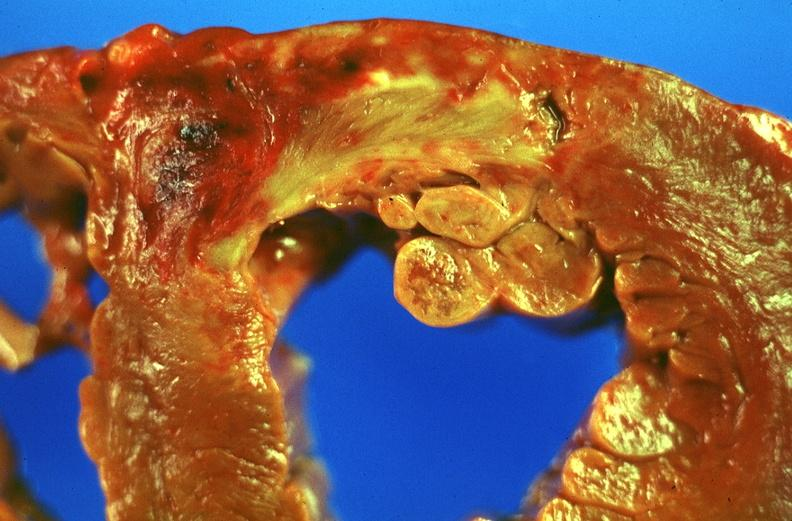what does this image show?
Answer the question using a single word or phrase. Acute myocardial infarction 